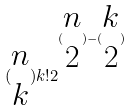Convert formula to latex. <formula><loc_0><loc_0><loc_500><loc_500>( \begin{matrix} n \\ k \end{matrix} ) k ! 2 ^ { ( \begin{matrix} n \\ 2 \end{matrix} ) - ( \begin{matrix} k \\ 2 \end{matrix} ) }</formula> 